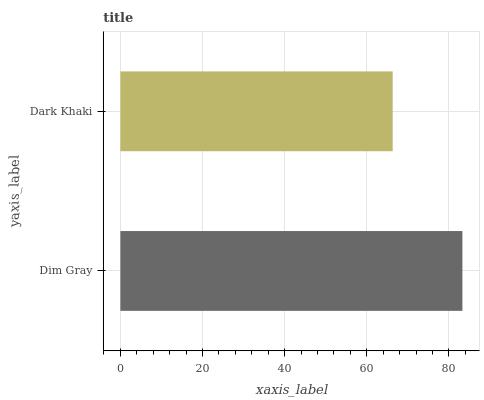Is Dark Khaki the minimum?
Answer yes or no. Yes. Is Dim Gray the maximum?
Answer yes or no. Yes. Is Dark Khaki the maximum?
Answer yes or no. No. Is Dim Gray greater than Dark Khaki?
Answer yes or no. Yes. Is Dark Khaki less than Dim Gray?
Answer yes or no. Yes. Is Dark Khaki greater than Dim Gray?
Answer yes or no. No. Is Dim Gray less than Dark Khaki?
Answer yes or no. No. Is Dim Gray the high median?
Answer yes or no. Yes. Is Dark Khaki the low median?
Answer yes or no. Yes. Is Dark Khaki the high median?
Answer yes or no. No. Is Dim Gray the low median?
Answer yes or no. No. 